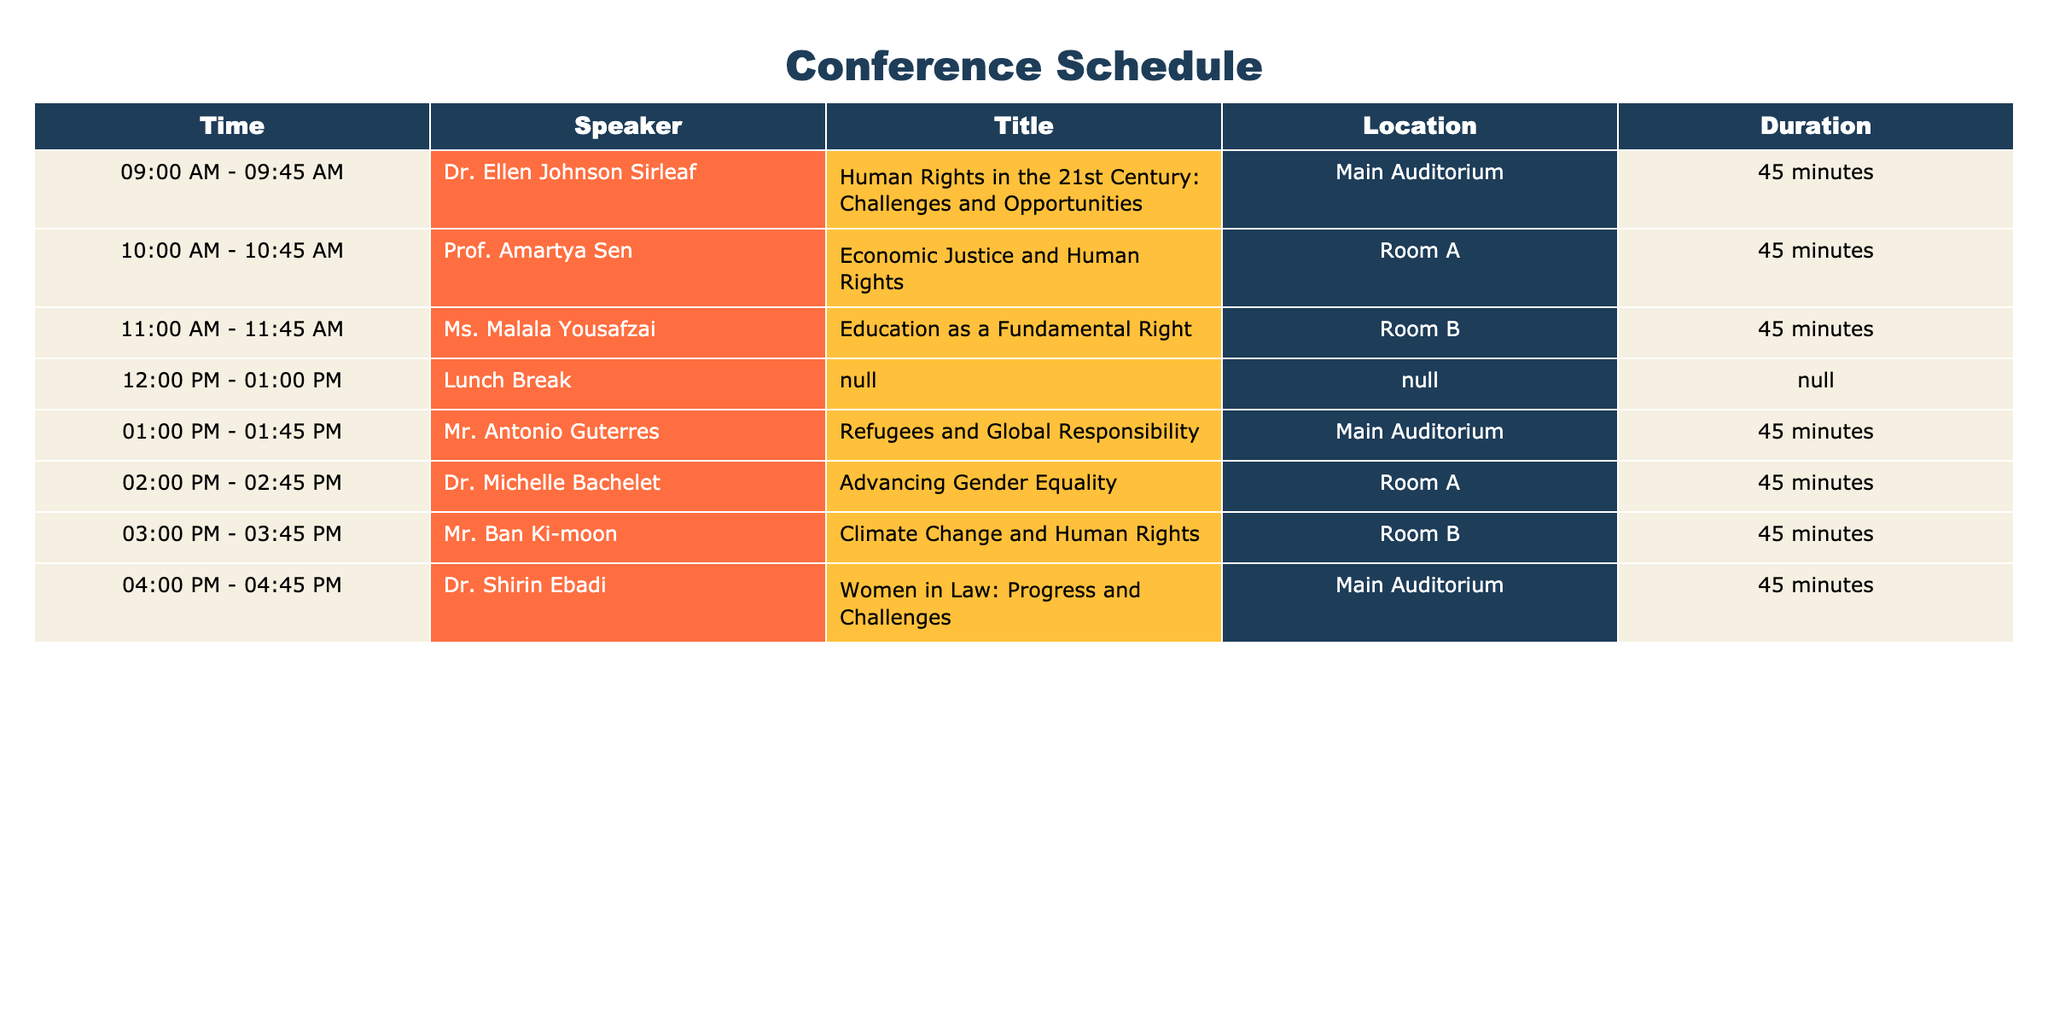What time does Dr. Ellen Johnson Sirleaf's keynote address start? The table specifically states that her address starts at 09:00 AM.
Answer: 09:00 AM Which speaker is discussing "Climate Change and Human Rights"? According to the table, Mr. Ban Ki-moon is the speaker for that topic.
Answer: Mr. Ban Ki-moon How many keynote addresses are scheduled before the lunch break? By looking at the table, the speakers from 09:00 AM to 12:00 PM cover three addresses before the lunch break starts.
Answer: 3 What is the duration of Dr. Michelle Bachelet's presentation? Dr. Michelle Bachelet's presentation is scheduled for 45 minutes, as stated in the table.
Answer: 45 minutes Are there any presentations scheduled in Room A after the lunch break? Looking at the table, there is one presentation scheduled in Room A after the lunch break, which is by Dr. Michelle Bachelet.
Answer: Yes What is the total duration of all keynote addresses before lunch? The total duration is the sum of three 45-minute addresses before lunch, which is 45 + 45 + 45 = 135 minutes.
Answer: 135 minutes Is "Education as a Fundamental Right" the title of the first presentation of the day? The table indicates that "Education as a Fundamental Right" is actually the third presentation of the day, after Dr. Ellen Johnson Sirleaf's and Prof. Amartya Sen's.
Answer: No Who is speaking in the Main Auditorium last? Dr. Shirin Ebadi is the last speaker in the Main Auditorium, as indicated in the table.
Answer: Dr. Shirin Ebadi If the schedule runs on time, what time will the conference end? The last presentation ends at 04:45 PM, so if everything runs on schedule, the conference will end at that time.
Answer: 04:45 PM 